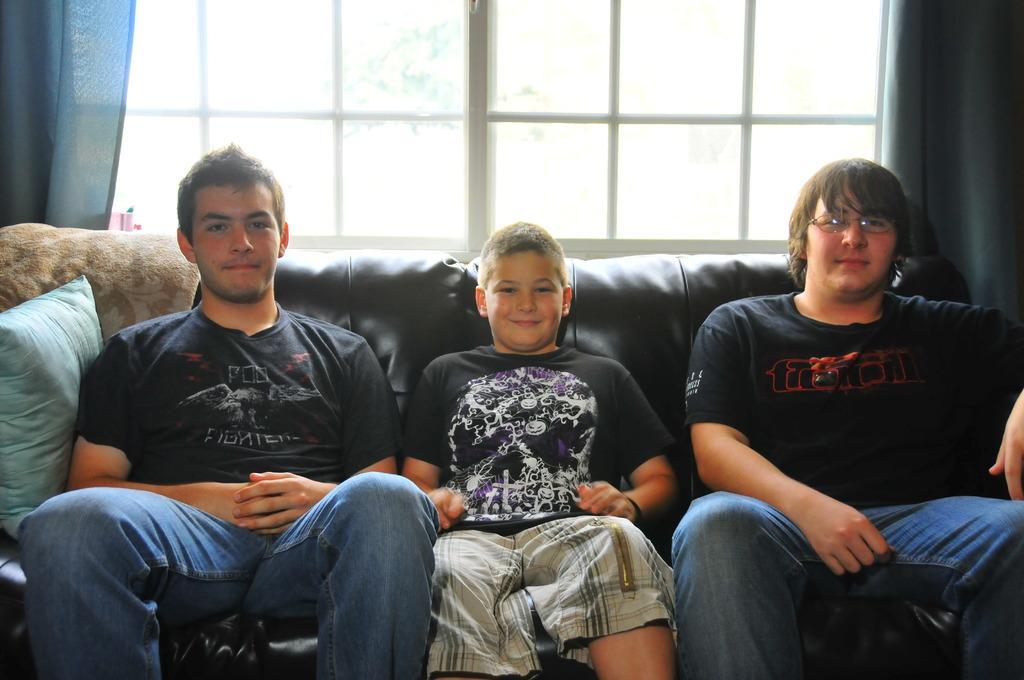Can you describe this image briefly? In this image we can see three boys sitting on a sofa. In the back there are windows with curtains. And one boy is wearing specs. 